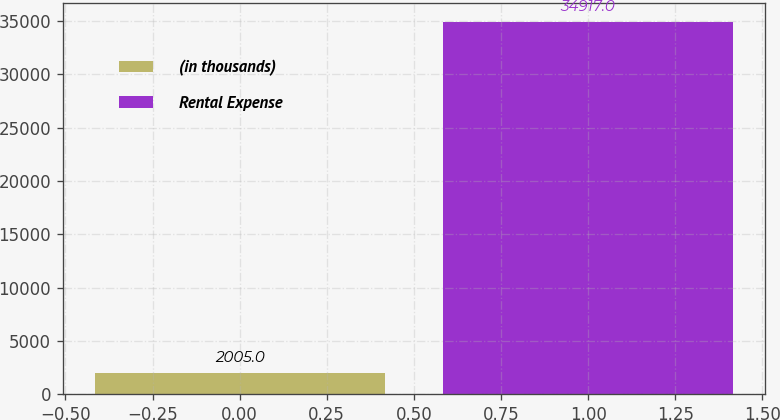<chart> <loc_0><loc_0><loc_500><loc_500><bar_chart><fcel>(in thousands)<fcel>Rental Expense<nl><fcel>2005<fcel>34917<nl></chart> 